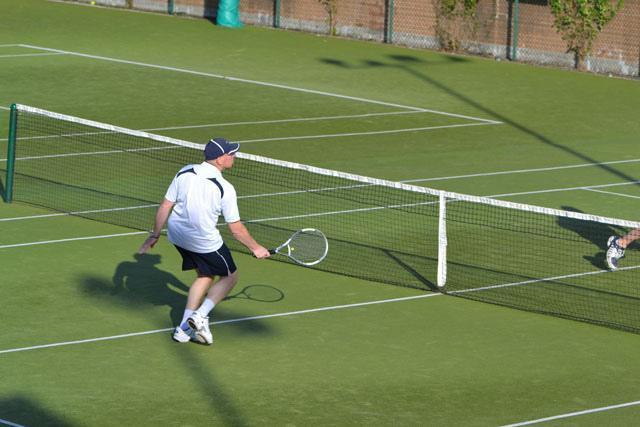How many courts can be seen?
Give a very brief answer. 2. 